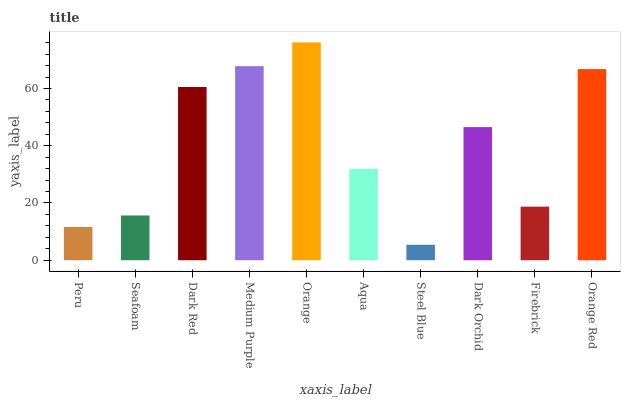Is Seafoam the minimum?
Answer yes or no. No. Is Seafoam the maximum?
Answer yes or no. No. Is Seafoam greater than Peru?
Answer yes or no. Yes. Is Peru less than Seafoam?
Answer yes or no. Yes. Is Peru greater than Seafoam?
Answer yes or no. No. Is Seafoam less than Peru?
Answer yes or no. No. Is Dark Orchid the high median?
Answer yes or no. Yes. Is Aqua the low median?
Answer yes or no. Yes. Is Dark Red the high median?
Answer yes or no. No. Is Medium Purple the low median?
Answer yes or no. No. 